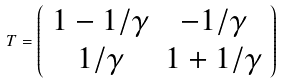<formula> <loc_0><loc_0><loc_500><loc_500>T = \left ( \begin{array} { c c } 1 - 1 / \gamma & - 1 / \gamma \\ 1 / \gamma & 1 + 1 / \gamma \end{array} \right )</formula> 